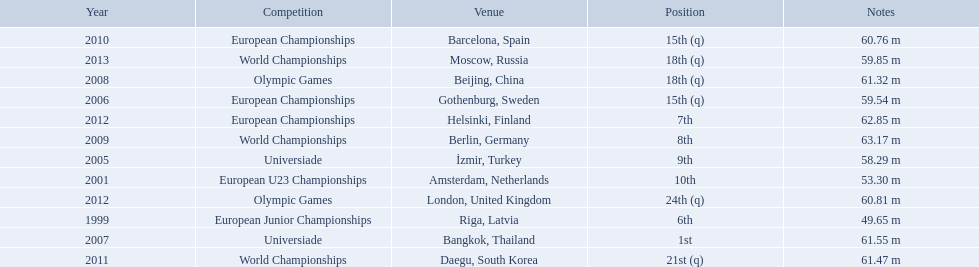What are all the competitions? European Junior Championships, European U23 Championships, Universiade, European Championships, Universiade, Olympic Games, World Championships, European Championships, World Championships, European Championships, Olympic Games, World Championships. What years did they place in the top 10? 1999, 2001, 2005, 2007, 2009, 2012. Besides when they placed first, which position was their highest? 6th. What are the years that gerhard mayer participated? 1999, 2001, 2005, 2006, 2007, 2008, 2009, 2010, 2011, 2012, 2012, 2013. Which years were earlier than 2007? 1999, 2001, 2005, 2006. What was the best placing for these years? 6th. What european junior championships? 6th. Would you mind parsing the complete table? {'header': ['Year', 'Competition', 'Venue', 'Position', 'Notes'], 'rows': [['2010', 'European Championships', 'Barcelona, Spain', '15th (q)', '60.76 m'], ['2013', 'World Championships', 'Moscow, Russia', '18th (q)', '59.85 m'], ['2008', 'Olympic Games', 'Beijing, China', '18th (q)', '61.32 m'], ['2006', 'European Championships', 'Gothenburg, Sweden', '15th (q)', '59.54 m'], ['2012', 'European Championships', 'Helsinki, Finland', '7th', '62.85 m'], ['2009', 'World Championships', 'Berlin, Germany', '8th', '63.17 m'], ['2005', 'Universiade', 'İzmir, Turkey', '9th', '58.29 m'], ['2001', 'European U23 Championships', 'Amsterdam, Netherlands', '10th', '53.30 m'], ['2012', 'Olympic Games', 'London, United Kingdom', '24th (q)', '60.81 m'], ['1999', 'European Junior Championships', 'Riga, Latvia', '6th', '49.65 m'], ['2007', 'Universiade', 'Bangkok, Thailand', '1st', '61.55 m'], ['2011', 'World Championships', 'Daegu, South Korea', '21st (q)', '61.47 m']]} What waseuropean junior championships best result? 63.17 m. 